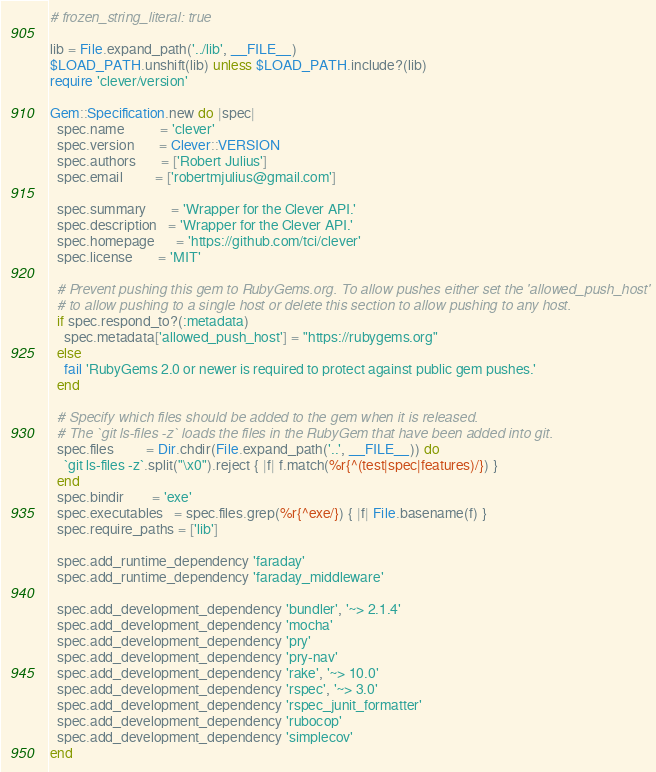<code> <loc_0><loc_0><loc_500><loc_500><_Ruby_># frozen_string_literal: true

lib = File.expand_path('../lib', __FILE__)
$LOAD_PATH.unshift(lib) unless $LOAD_PATH.include?(lib)
require 'clever/version'

Gem::Specification.new do |spec|
  spec.name          = 'clever'
  spec.version       = Clever::VERSION
  spec.authors       = ['Robert Julius']
  spec.email         = ['robertmjulius@gmail.com']

  spec.summary       = 'Wrapper for the Clever API.'
  spec.description   = 'Wrapper for the Clever API.'
  spec.homepage      = 'https://github.com/tci/clever'
  spec.license       = 'MIT'

  # Prevent pushing this gem to RubyGems.org. To allow pushes either set the 'allowed_push_host'
  # to allow pushing to a single host or delete this section to allow pushing to any host.
  if spec.respond_to?(:metadata)
    spec.metadata['allowed_push_host'] = "https://rubygems.org"
  else
    fail 'RubyGems 2.0 or newer is required to protect against public gem pushes.'
  end

  # Specify which files should be added to the gem when it is released.
  # The `git ls-files -z` loads the files in the RubyGem that have been added into git.
  spec.files         = Dir.chdir(File.expand_path('..', __FILE__)) do
    `git ls-files -z`.split("\x0").reject { |f| f.match(%r{^(test|spec|features)/}) }
  end
  spec.bindir        = 'exe'
  spec.executables   = spec.files.grep(%r{^exe/}) { |f| File.basename(f) }
  spec.require_paths = ['lib']

  spec.add_runtime_dependency 'faraday'
  spec.add_runtime_dependency 'faraday_middleware'

  spec.add_development_dependency 'bundler', '~> 2.1.4'
  spec.add_development_dependency 'mocha'
  spec.add_development_dependency 'pry'
  spec.add_development_dependency 'pry-nav'
  spec.add_development_dependency 'rake', '~> 10.0'
  spec.add_development_dependency 'rspec', '~> 3.0'
  spec.add_development_dependency 'rspec_junit_formatter'
  spec.add_development_dependency 'rubocop'
  spec.add_development_dependency 'simplecov'
end
</code> 